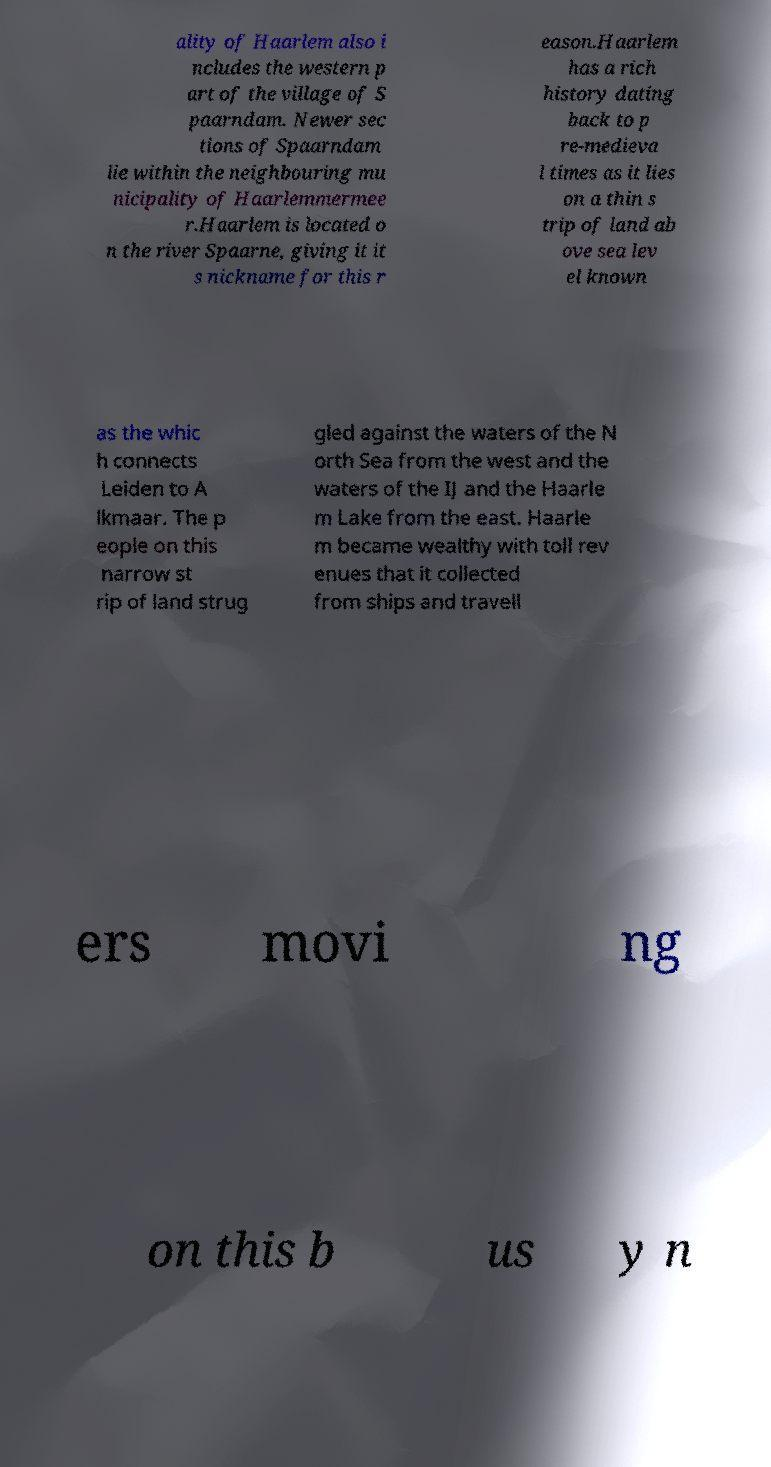There's text embedded in this image that I need extracted. Can you transcribe it verbatim? ality of Haarlem also i ncludes the western p art of the village of S paarndam. Newer sec tions of Spaarndam lie within the neighbouring mu nicipality of Haarlemmermee r.Haarlem is located o n the river Spaarne, giving it it s nickname for this r eason.Haarlem has a rich history dating back to p re-medieva l times as it lies on a thin s trip of land ab ove sea lev el known as the whic h connects Leiden to A lkmaar. The p eople on this narrow st rip of land strug gled against the waters of the N orth Sea from the west and the waters of the IJ and the Haarle m Lake from the east. Haarle m became wealthy with toll rev enues that it collected from ships and travell ers movi ng on this b us y n 